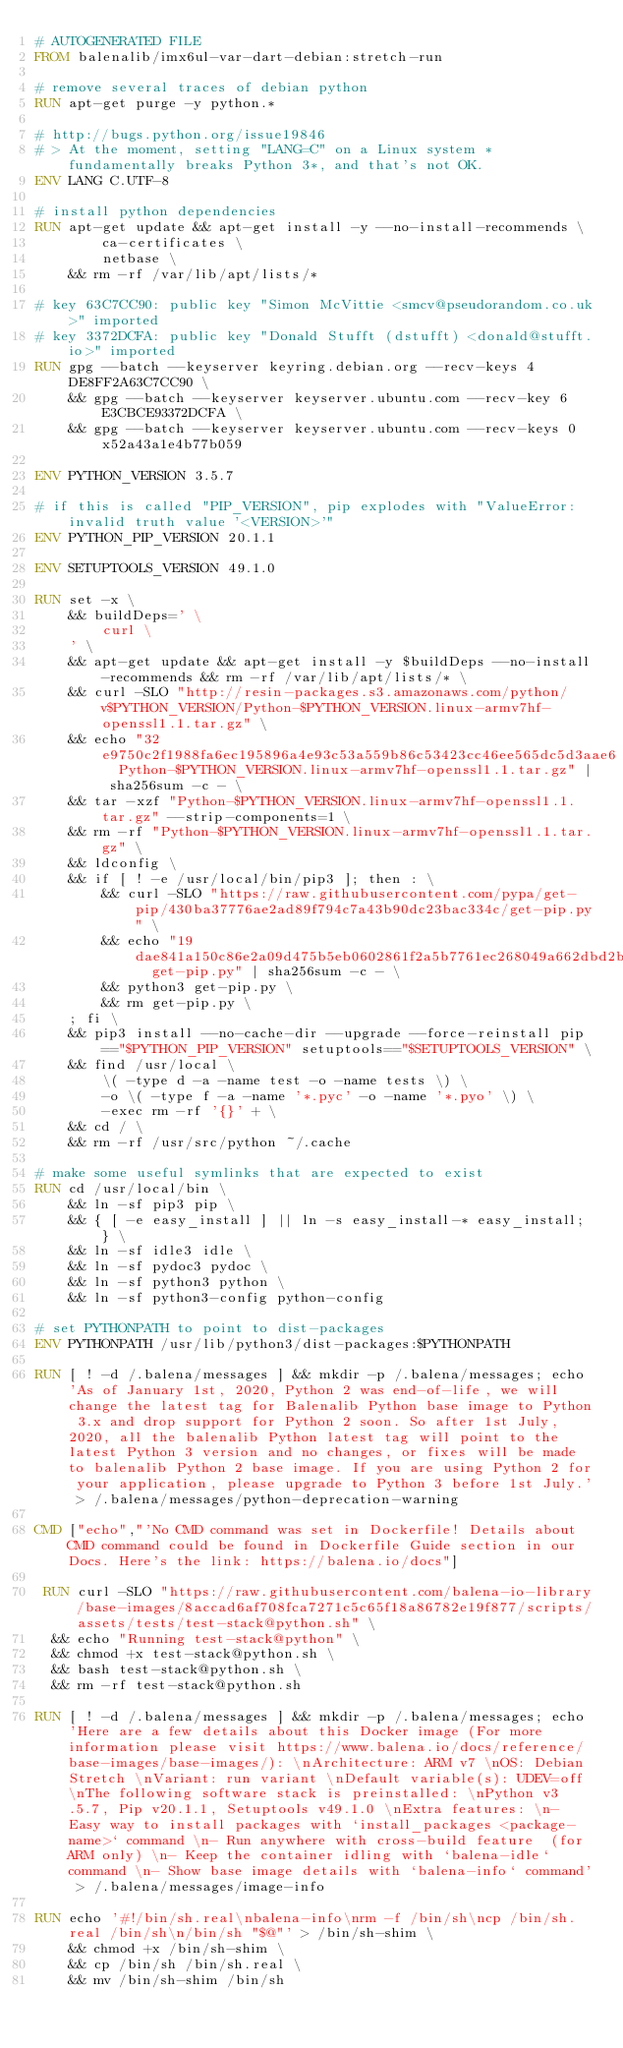Convert code to text. <code><loc_0><loc_0><loc_500><loc_500><_Dockerfile_># AUTOGENERATED FILE
FROM balenalib/imx6ul-var-dart-debian:stretch-run

# remove several traces of debian python
RUN apt-get purge -y python.*

# http://bugs.python.org/issue19846
# > At the moment, setting "LANG=C" on a Linux system *fundamentally breaks Python 3*, and that's not OK.
ENV LANG C.UTF-8

# install python dependencies
RUN apt-get update && apt-get install -y --no-install-recommends \
		ca-certificates \
		netbase \
	&& rm -rf /var/lib/apt/lists/*

# key 63C7CC90: public key "Simon McVittie <smcv@pseudorandom.co.uk>" imported
# key 3372DCFA: public key "Donald Stufft (dstufft) <donald@stufft.io>" imported
RUN gpg --batch --keyserver keyring.debian.org --recv-keys 4DE8FF2A63C7CC90 \
	&& gpg --batch --keyserver keyserver.ubuntu.com --recv-key 6E3CBCE93372DCFA \
	&& gpg --batch --keyserver keyserver.ubuntu.com --recv-keys 0x52a43a1e4b77b059

ENV PYTHON_VERSION 3.5.7

# if this is called "PIP_VERSION", pip explodes with "ValueError: invalid truth value '<VERSION>'"
ENV PYTHON_PIP_VERSION 20.1.1

ENV SETUPTOOLS_VERSION 49.1.0

RUN set -x \
	&& buildDeps=' \
		curl \
	' \
	&& apt-get update && apt-get install -y $buildDeps --no-install-recommends && rm -rf /var/lib/apt/lists/* \
	&& curl -SLO "http://resin-packages.s3.amazonaws.com/python/v$PYTHON_VERSION/Python-$PYTHON_VERSION.linux-armv7hf-openssl1.1.tar.gz" \
	&& echo "32e9750c2f1988fa6ec195896a4e93c53a559b86c53423cc46ee565dc5d3aae6  Python-$PYTHON_VERSION.linux-armv7hf-openssl1.1.tar.gz" | sha256sum -c - \
	&& tar -xzf "Python-$PYTHON_VERSION.linux-armv7hf-openssl1.1.tar.gz" --strip-components=1 \
	&& rm -rf "Python-$PYTHON_VERSION.linux-armv7hf-openssl1.1.tar.gz" \
	&& ldconfig \
	&& if [ ! -e /usr/local/bin/pip3 ]; then : \
		&& curl -SLO "https://raw.githubusercontent.com/pypa/get-pip/430ba37776ae2ad89f794c7a43b90dc23bac334c/get-pip.py" \
		&& echo "19dae841a150c86e2a09d475b5eb0602861f2a5b7761ec268049a662dbd2bd0c  get-pip.py" | sha256sum -c - \
		&& python3 get-pip.py \
		&& rm get-pip.py \
	; fi \
	&& pip3 install --no-cache-dir --upgrade --force-reinstall pip=="$PYTHON_PIP_VERSION" setuptools=="$SETUPTOOLS_VERSION" \
	&& find /usr/local \
		\( -type d -a -name test -o -name tests \) \
		-o \( -type f -a -name '*.pyc' -o -name '*.pyo' \) \
		-exec rm -rf '{}' + \
	&& cd / \
	&& rm -rf /usr/src/python ~/.cache

# make some useful symlinks that are expected to exist
RUN cd /usr/local/bin \
	&& ln -sf pip3 pip \
	&& { [ -e easy_install ] || ln -s easy_install-* easy_install; } \
	&& ln -sf idle3 idle \
	&& ln -sf pydoc3 pydoc \
	&& ln -sf python3 python \
	&& ln -sf python3-config python-config

# set PYTHONPATH to point to dist-packages
ENV PYTHONPATH /usr/lib/python3/dist-packages:$PYTHONPATH

RUN [ ! -d /.balena/messages ] && mkdir -p /.balena/messages; echo 'As of January 1st, 2020, Python 2 was end-of-life, we will change the latest tag for Balenalib Python base image to Python 3.x and drop support for Python 2 soon. So after 1st July, 2020, all the balenalib Python latest tag will point to the latest Python 3 version and no changes, or fixes will be made to balenalib Python 2 base image. If you are using Python 2 for your application, please upgrade to Python 3 before 1st July.' > /.balena/messages/python-deprecation-warning

CMD ["echo","'No CMD command was set in Dockerfile! Details about CMD command could be found in Dockerfile Guide section in our Docs. Here's the link: https://balena.io/docs"]

 RUN curl -SLO "https://raw.githubusercontent.com/balena-io-library/base-images/8accad6af708fca7271c5c65f18a86782e19f877/scripts/assets/tests/test-stack@python.sh" \
  && echo "Running test-stack@python" \
  && chmod +x test-stack@python.sh \
  && bash test-stack@python.sh \
  && rm -rf test-stack@python.sh 

RUN [ ! -d /.balena/messages ] && mkdir -p /.balena/messages; echo 'Here are a few details about this Docker image (For more information please visit https://www.balena.io/docs/reference/base-images/base-images/): \nArchitecture: ARM v7 \nOS: Debian Stretch \nVariant: run variant \nDefault variable(s): UDEV=off \nThe following software stack is preinstalled: \nPython v3.5.7, Pip v20.1.1, Setuptools v49.1.0 \nExtra features: \n- Easy way to install packages with `install_packages <package-name>` command \n- Run anywhere with cross-build feature  (for ARM only) \n- Keep the container idling with `balena-idle` command \n- Show base image details with `balena-info` command' > /.balena/messages/image-info

RUN echo '#!/bin/sh.real\nbalena-info\nrm -f /bin/sh\ncp /bin/sh.real /bin/sh\n/bin/sh "$@"' > /bin/sh-shim \
	&& chmod +x /bin/sh-shim \
	&& cp /bin/sh /bin/sh.real \
	&& mv /bin/sh-shim /bin/sh</code> 